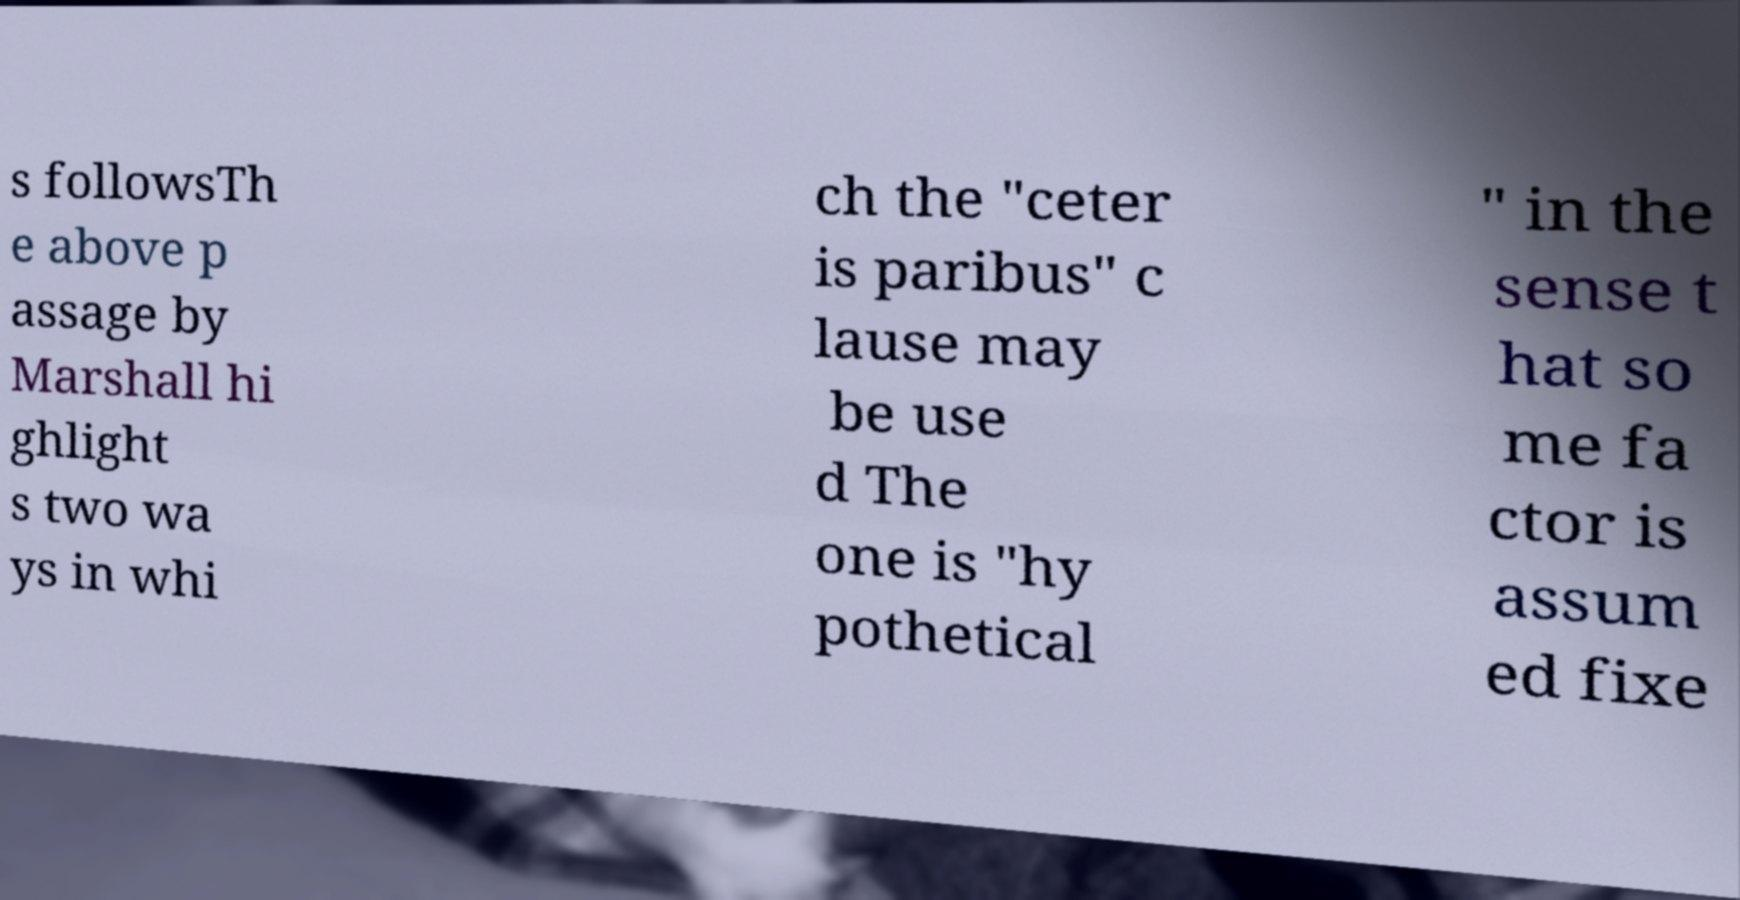I need the written content from this picture converted into text. Can you do that? s followsTh e above p assage by Marshall hi ghlight s two wa ys in whi ch the "ceter is paribus" c lause may be use d The one is "hy pothetical " in the sense t hat so me fa ctor is assum ed fixe 